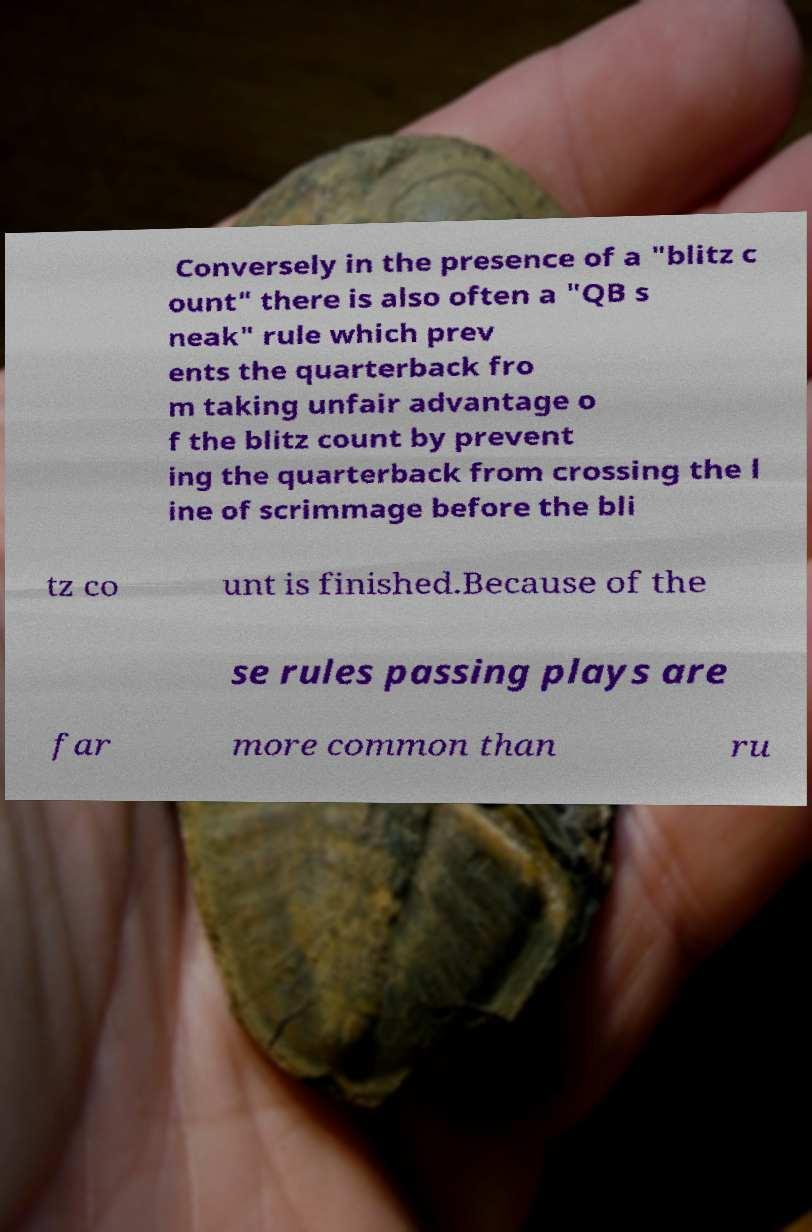What messages or text are displayed in this image? I need them in a readable, typed format. Conversely in the presence of a "blitz c ount" there is also often a "QB s neak" rule which prev ents the quarterback fro m taking unfair advantage o f the blitz count by prevent ing the quarterback from crossing the l ine of scrimmage before the bli tz co unt is finished.Because of the se rules passing plays are far more common than ru 